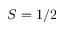<formula> <loc_0><loc_0><loc_500><loc_500>S = 1 / 2</formula> 